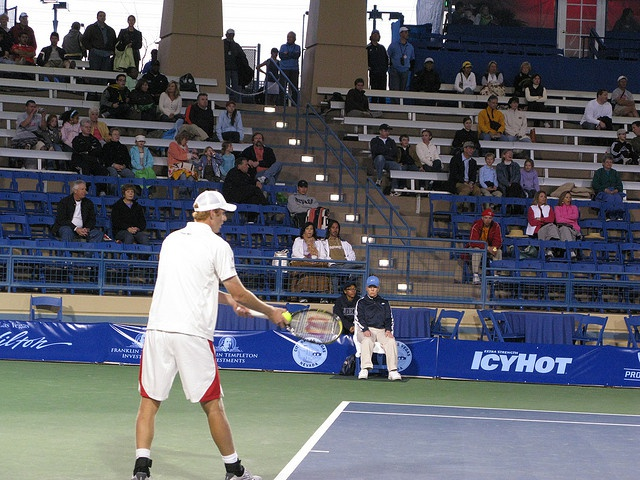Describe the objects in this image and their specific colors. I can see people in lightgray, black, gray, navy, and maroon tones, chair in lightgray, black, navy, and gray tones, bench in lightgray, black, navy, and gray tones, people in lightgray, white, gray, darkgray, and tan tones, and people in lightgray, black, and darkgray tones in this image. 